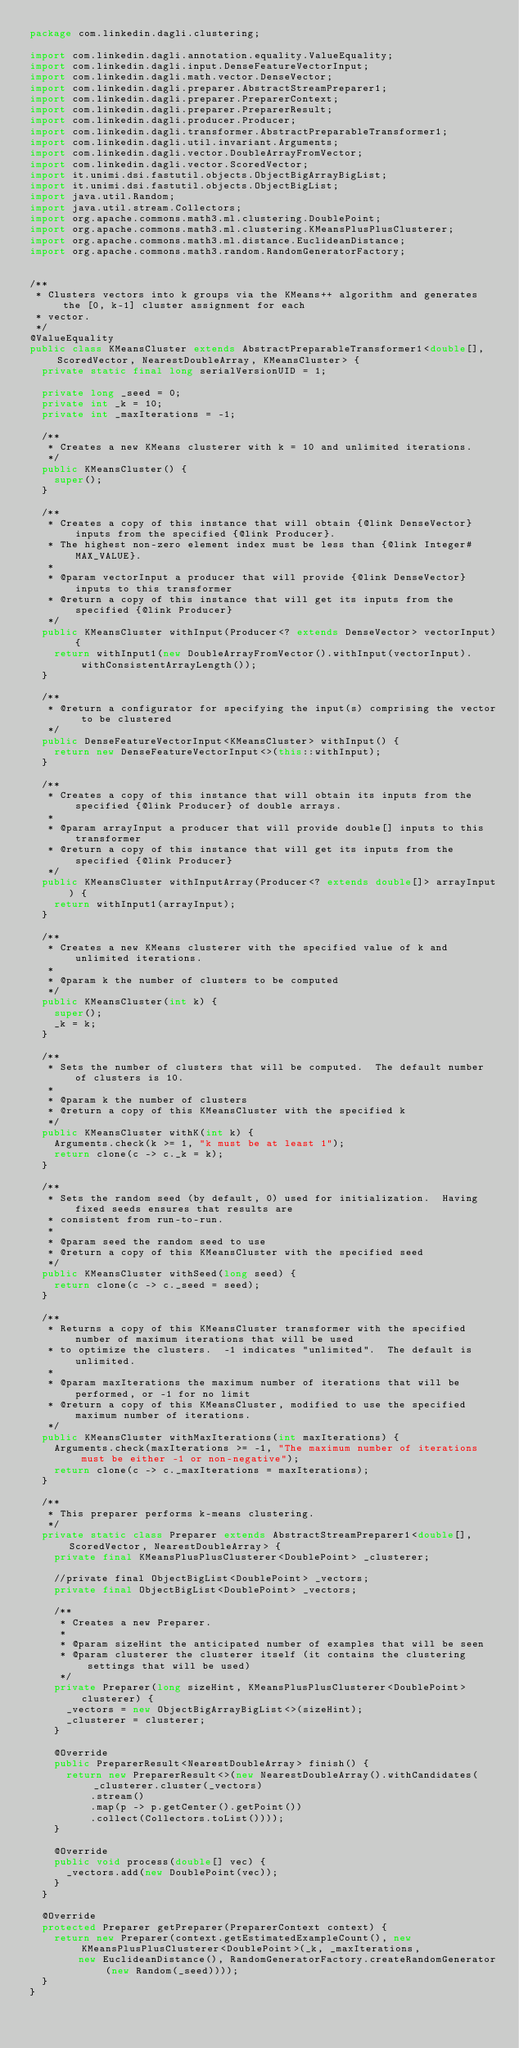Convert code to text. <code><loc_0><loc_0><loc_500><loc_500><_Java_>package com.linkedin.dagli.clustering;

import com.linkedin.dagli.annotation.equality.ValueEquality;
import com.linkedin.dagli.input.DenseFeatureVectorInput;
import com.linkedin.dagli.math.vector.DenseVector;
import com.linkedin.dagli.preparer.AbstractStreamPreparer1;
import com.linkedin.dagli.preparer.PreparerContext;
import com.linkedin.dagli.preparer.PreparerResult;
import com.linkedin.dagli.producer.Producer;
import com.linkedin.dagli.transformer.AbstractPreparableTransformer1;
import com.linkedin.dagli.util.invariant.Arguments;
import com.linkedin.dagli.vector.DoubleArrayFromVector;
import com.linkedin.dagli.vector.ScoredVector;
import it.unimi.dsi.fastutil.objects.ObjectBigArrayBigList;
import it.unimi.dsi.fastutil.objects.ObjectBigList;
import java.util.Random;
import java.util.stream.Collectors;
import org.apache.commons.math3.ml.clustering.DoublePoint;
import org.apache.commons.math3.ml.clustering.KMeansPlusPlusClusterer;
import org.apache.commons.math3.ml.distance.EuclideanDistance;
import org.apache.commons.math3.random.RandomGeneratorFactory;


/**
 * Clusters vectors into k groups via the KMeans++ algorithm and generates the [0, k-1] cluster assignment for each
 * vector.
 */
@ValueEquality
public class KMeansCluster extends AbstractPreparableTransformer1<double[], ScoredVector, NearestDoubleArray, KMeansCluster> {
  private static final long serialVersionUID = 1;

  private long _seed = 0;
  private int _k = 10;
  private int _maxIterations = -1;

  /**
   * Creates a new KMeans clusterer with k = 10 and unlimited iterations.
   */
  public KMeansCluster() {
    super();
  }

  /**
   * Creates a copy of this instance that will obtain {@link DenseVector} inputs from the specified {@link Producer}.
   * The highest non-zero element index must be less than {@link Integer#MAX_VALUE}.
   *
   * @param vectorInput a producer that will provide {@link DenseVector} inputs to this transformer
   * @return a copy of this instance that will get its inputs from the specified {@link Producer}
   */
  public KMeansCluster withInput(Producer<? extends DenseVector> vectorInput) {
    return withInput1(new DoubleArrayFromVector().withInput(vectorInput).withConsistentArrayLength());
  }

  /**
   * @return a configurator for specifying the input(s) comprising the vector to be clustered
   */
  public DenseFeatureVectorInput<KMeansCluster> withInput() {
    return new DenseFeatureVectorInput<>(this::withInput);
  }

  /**
   * Creates a copy of this instance that will obtain its inputs from the specified {@link Producer} of double arrays.
   *
   * @param arrayInput a producer that will provide double[] inputs to this transformer
   * @return a copy of this instance that will get its inputs from the specified {@link Producer}
   */
  public KMeansCluster withInputArray(Producer<? extends double[]> arrayInput) {
    return withInput1(arrayInput);
  }

  /**
   * Creates a new KMeans clusterer with the specified value of k and unlimited iterations.
   *
   * @param k the number of clusters to be computed
   */
  public KMeansCluster(int k) {
    super();
    _k = k;
  }

  /**
   * Sets the number of clusters that will be computed.  The default number of clusters is 10.
   *
   * @param k the number of clusters
   * @return a copy of this KMeansCluster with the specified k
   */
  public KMeansCluster withK(int k) {
    Arguments.check(k >= 1, "k must be at least 1");
    return clone(c -> c._k = k);
  }

  /**
   * Sets the random seed (by default, 0) used for initialization.  Having fixed seeds ensures that results are
   * consistent from run-to-run.
   *
   * @param seed the random seed to use
   * @return a copy of this KMeansCluster with the specified seed
   */
  public KMeansCluster withSeed(long seed) {
    return clone(c -> c._seed = seed);
  }

  /**
   * Returns a copy of this KMeansCluster transformer with the specified number of maximum iterations that will be used
   * to optimize the clusters.  -1 indicates "unlimited".  The default is unlimited.
   *
   * @param maxIterations the maximum number of iterations that will be performed, or -1 for no limit
   * @return a copy of this KMeansCluster, modified to use the specified maximum number of iterations.
   */
  public KMeansCluster withMaxIterations(int maxIterations) {
    Arguments.check(maxIterations >= -1, "The maximum number of iterations must be either -1 or non-negative");
    return clone(c -> c._maxIterations = maxIterations);
  }

  /**
   * This preparer performs k-means clustering.
   */
  private static class Preparer extends AbstractStreamPreparer1<double[], ScoredVector, NearestDoubleArray> {
    private final KMeansPlusPlusClusterer<DoublePoint> _clusterer;

    //private final ObjectBigList<DoublePoint> _vectors;
    private final ObjectBigList<DoublePoint> _vectors;

    /**
     * Creates a new Preparer.
     *
     * @param sizeHint the anticipated number of examples that will be seen
     * @param clusterer the clusterer itself (it contains the clustering settings that will be used)
     */
    private Preparer(long sizeHint, KMeansPlusPlusClusterer<DoublePoint> clusterer) {
      _vectors = new ObjectBigArrayBigList<>(sizeHint);
      _clusterer = clusterer;
    }

    @Override
    public PreparerResult<NearestDoubleArray> finish() {
      return new PreparerResult<>(new NearestDoubleArray().withCandidates(_clusterer.cluster(_vectors)
          .stream()
          .map(p -> p.getCenter().getPoint())
          .collect(Collectors.toList())));
    }

    @Override
    public void process(double[] vec) {
      _vectors.add(new DoublePoint(vec));
    }
  }

  @Override
  protected Preparer getPreparer(PreparerContext context) {
    return new Preparer(context.getEstimatedExampleCount(), new KMeansPlusPlusClusterer<DoublePoint>(_k, _maxIterations,
        new EuclideanDistance(), RandomGeneratorFactory.createRandomGenerator(new Random(_seed))));
  }
}
</code> 